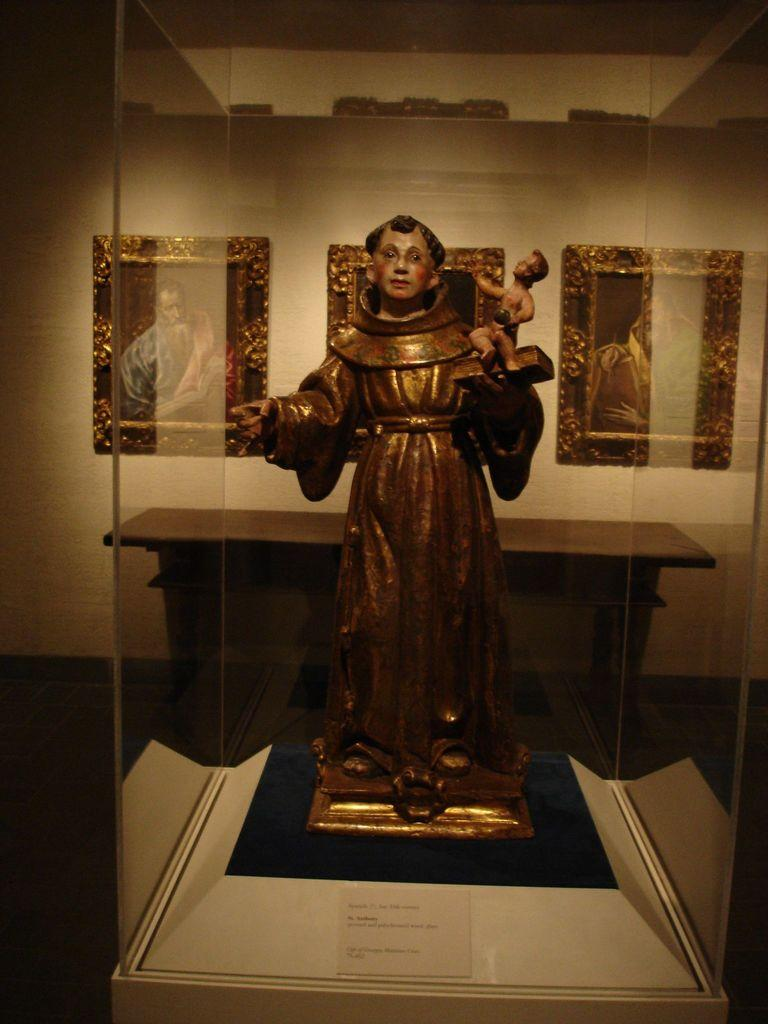What is the main object in the image? There is a glass box in the image. What is inside the glass box? A statue of a person is inside the glass box. What can be seen in the background of the image? There is a wall in the background of the image. What is attached to the wall in the background? There are photo frames attached to the wall in the background. What type of heart can be seen beating inside the glass box? There is no heart visible inside the glass box; it contains a statue of a person. 